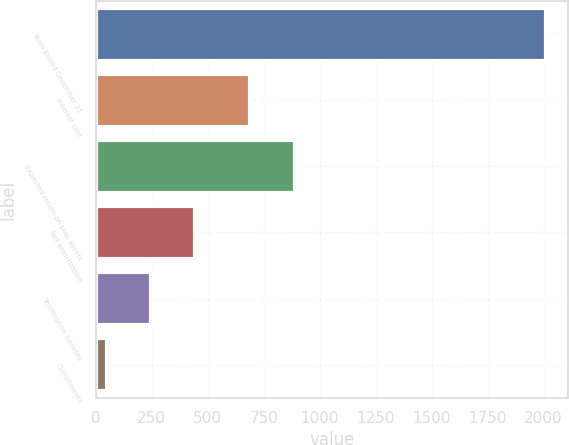Convert chart to OTSL. <chart><loc_0><loc_0><loc_500><loc_500><bar_chart><fcel>Years Ended December 31<fcel>Interest cost<fcel>Expected return on plan assets<fcel>Net amortization<fcel>Termination benefits<fcel>Curtailments<nl><fcel>2010<fcel>688<fcel>891<fcel>442<fcel>246<fcel>50<nl></chart> 